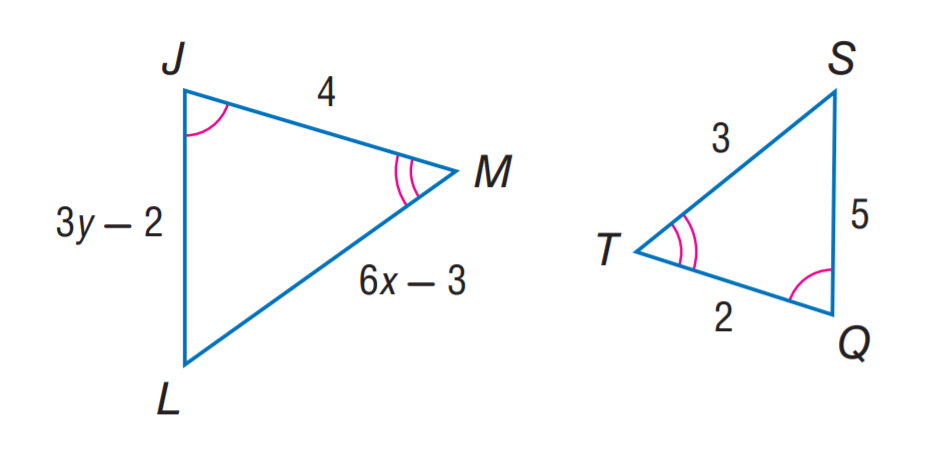Answer the mathemtical geometry problem and directly provide the correct option letter.
Question: Find y if \triangle J L M \sim \triangle Q S T.
Choices: A: 3 B: 4 C: 5 D: 6 B 